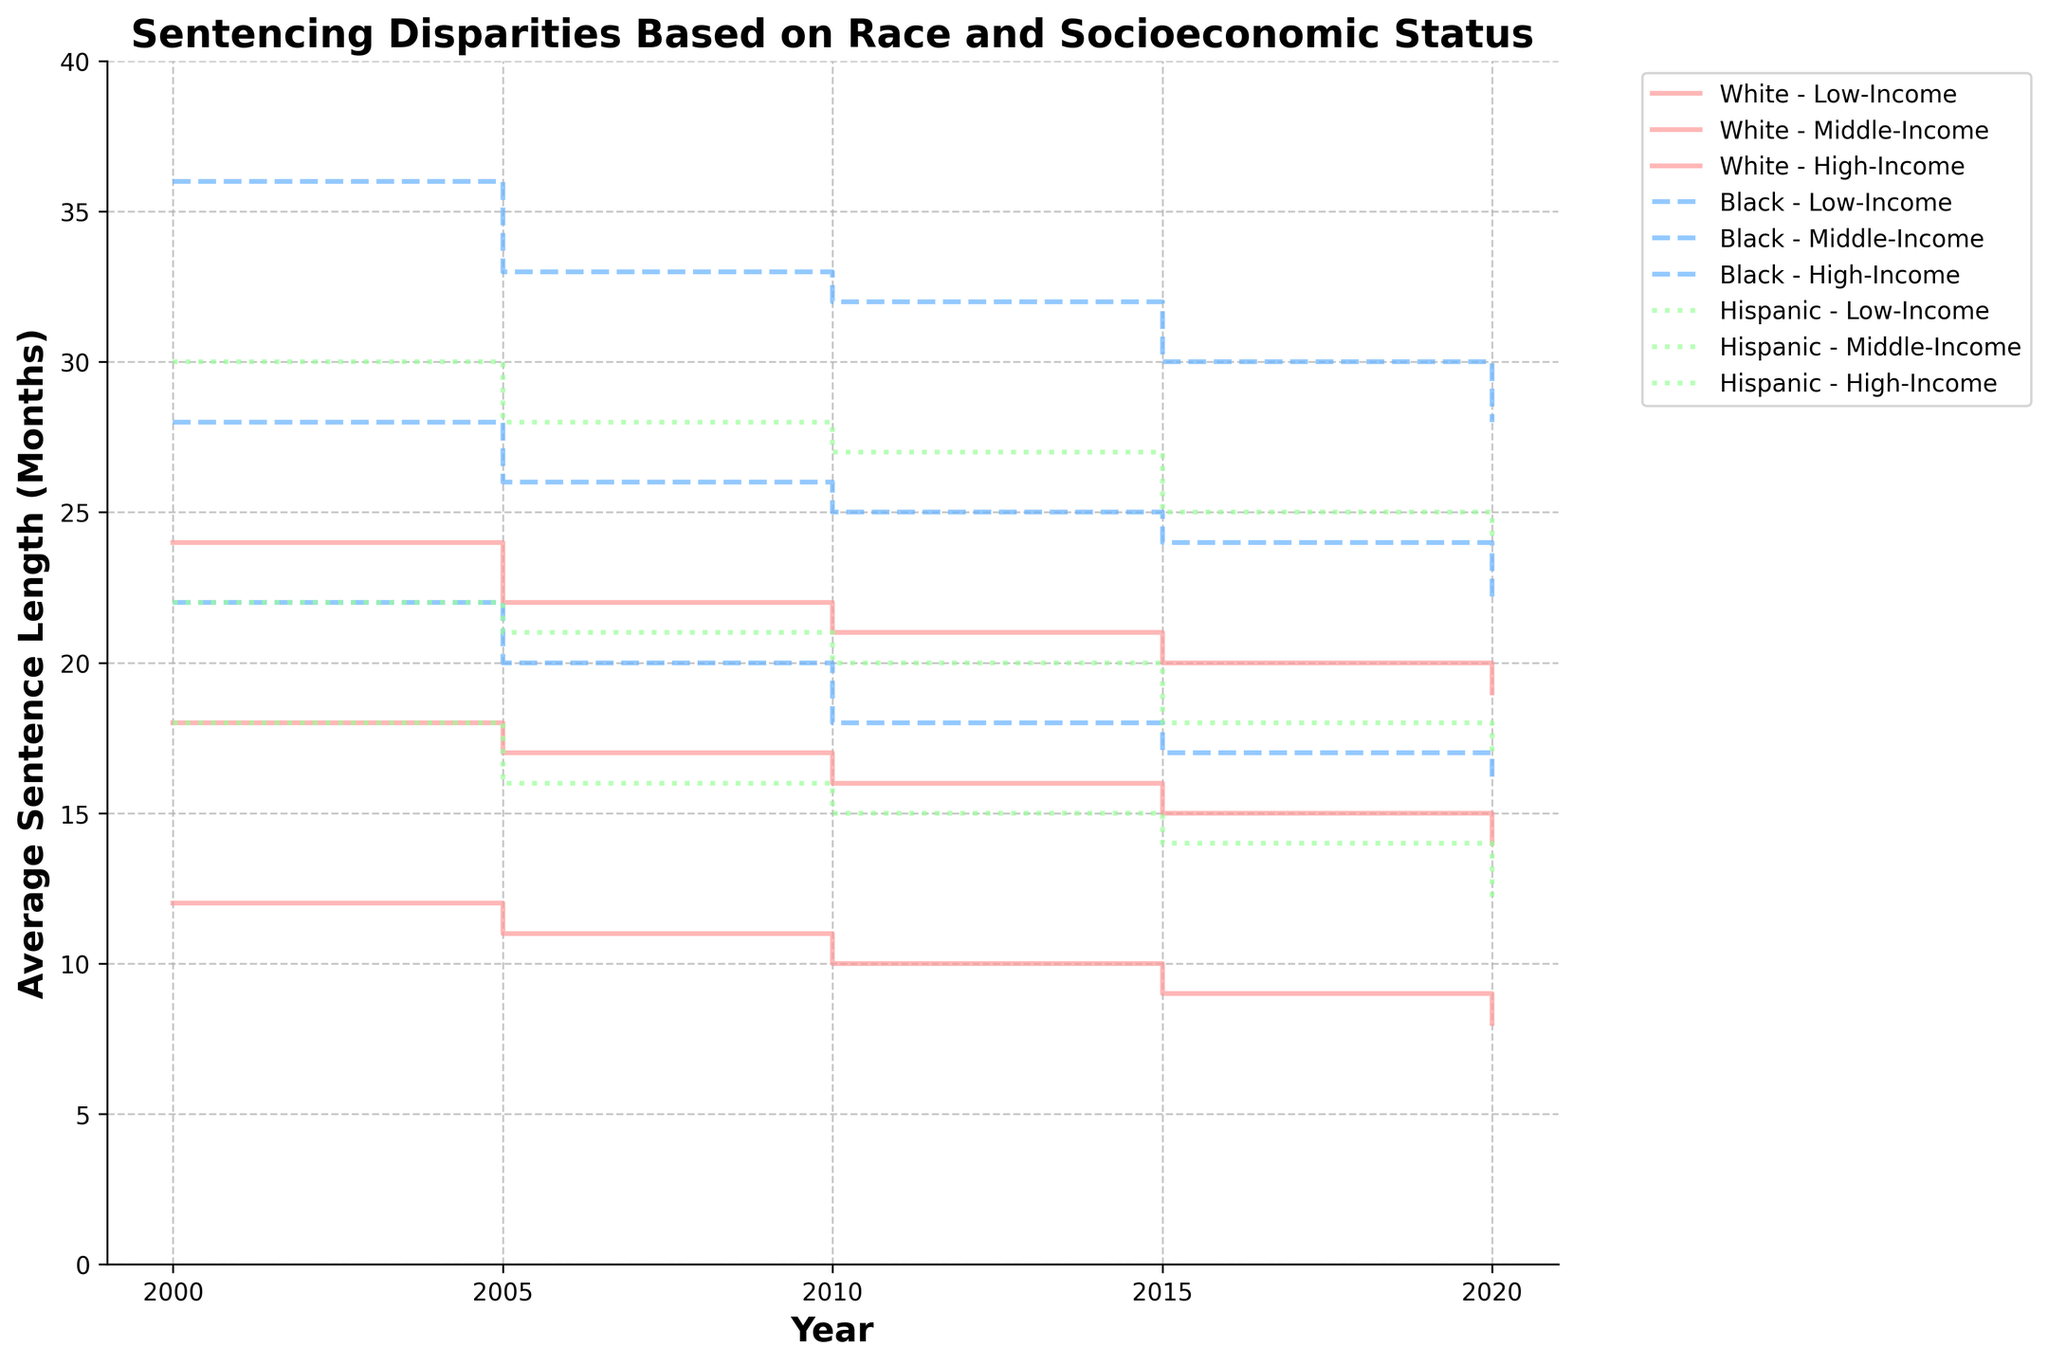What's the title of the figure? The title is typically placed at the top of the figure for easy identification.
Answer: Sentencing Disparities Based on Race and Socioeconomic Status Which race and income group had the longest average sentence in the year 2000? By looking at the stair plot for the year 2000, we can check the height of the steps to identify the group with the longest average sentence.
Answer: Black, Low-Income How has the average sentence length for Black, High-Income individuals changed from 2000 to 2020? Trace the steps in the plot corresponding to Black, High-Income individuals from 2000 to 2020, and note any increases or decreases.
Answer: It decreased from 22 months to 16 months In which year did White, High-Income individuals see the biggest drop in average sentence length? Analyze the change in step heights for White, High-Income individuals to identify the year with the most significant decrease.
Answer: 2005 Compare the average sentence lengths for Hispanic, Middle-Income individuals between 2005 and 2015. Which year had the shorter average sentence? Locate the steps for Hispanic, Middle-Income individuals in 2005 and 2015, and compare their heights.
Answer: 2015 What is the difference in average sentence lengths between Black, Low-Income and White, Low-Income individuals in 2010? By comparing the step heights for Black, Low-Income and White, Low-Income individuals in 2010, we can calculate the difference. Black, Low-Income: 32 months, White, Low-Income: 21 months, so the difference is 32 - 21 = 11.
Answer: 11 months Which racial and income group experienced the least change in average sentence length from 2000 to 2020? Examine the steps for each group from 2000 to 2020 to identify the group with the smallest difference in average sentence length.
Answer: Hispanic, High-Income How do the average sentence lengths for Hispanic, Low-Income individuals in 2020 compare to Black, Low-Income individuals in 2020? Compare the heights of the steps for Hispanic, Low-Income and Black, Low-Income individuals in 2020.
Answer: Hispanic, Low-Income individuals have shorter average sentences (24 months vs. 28 months) What's the general trend for average sentence lengths of Middle-Income individuals across all races from 2000 to 2020? By tracing the steps of Middle-Income individuals for all three races across the years, we can observe the direction of change.
Answer: The trend is generally decreasing 